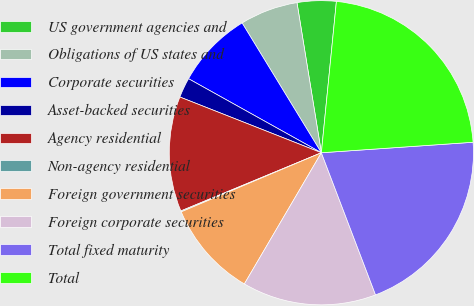Convert chart to OTSL. <chart><loc_0><loc_0><loc_500><loc_500><pie_chart><fcel>US government agencies and<fcel>Obligations of US states and<fcel>Corporate securities<fcel>Asset-backed securities<fcel>Agency residential<fcel>Non-agency residential<fcel>Foreign government securities<fcel>Foreign corporate securities<fcel>Total fixed maturity<fcel>Total<nl><fcel>4.14%<fcel>6.16%<fcel>8.18%<fcel>2.12%<fcel>12.22%<fcel>0.1%<fcel>10.2%<fcel>14.24%<fcel>20.3%<fcel>22.32%<nl></chart> 